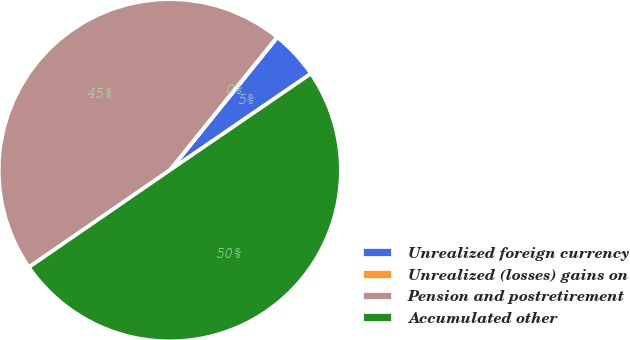Convert chart to OTSL. <chart><loc_0><loc_0><loc_500><loc_500><pie_chart><fcel>Unrealized foreign currency<fcel>Unrealized (losses) gains on<fcel>Pension and postretirement<fcel>Accumulated other<nl><fcel>4.62%<fcel>0.04%<fcel>45.38%<fcel>49.96%<nl></chart> 